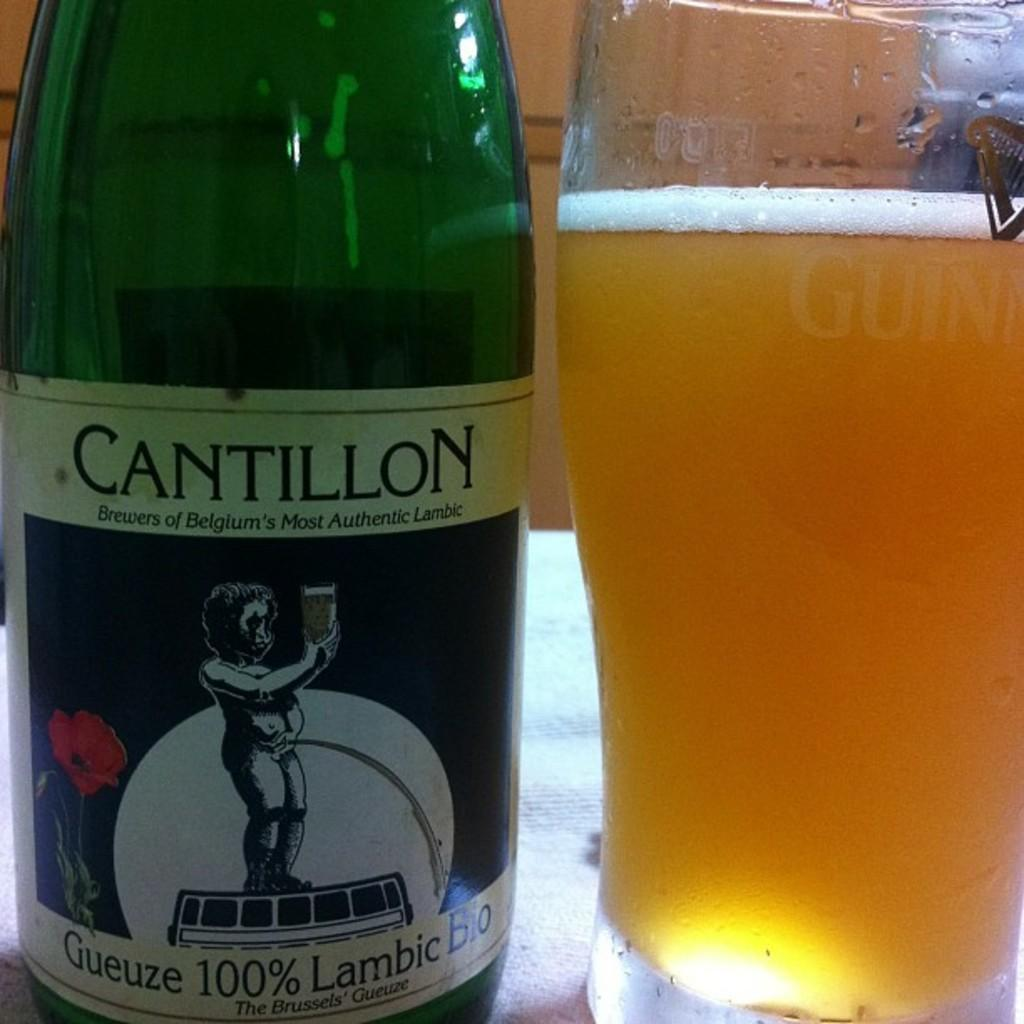<image>
Summarize the visual content of the image. A bottle of Cantillon sits next to a glass of beer. 